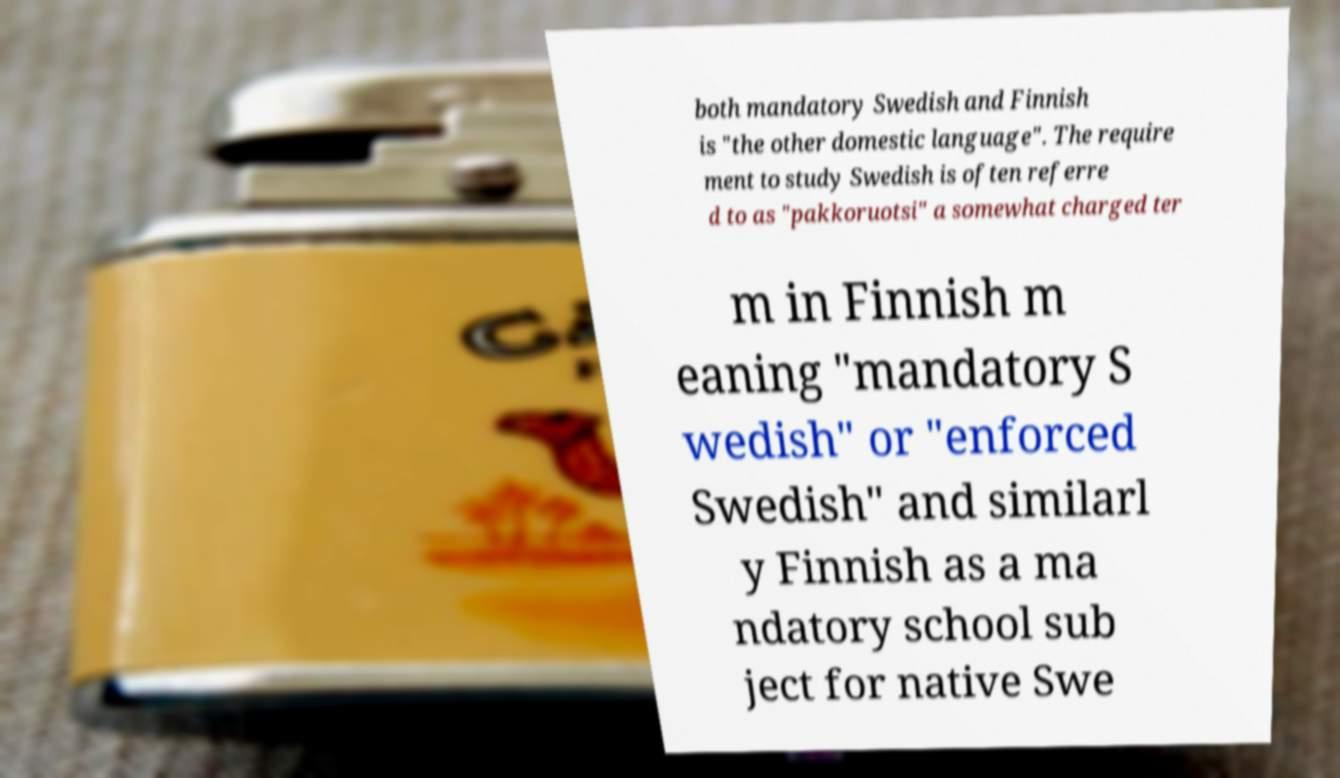Can you read and provide the text displayed in the image?This photo seems to have some interesting text. Can you extract and type it out for me? both mandatory Swedish and Finnish is "the other domestic language". The require ment to study Swedish is often referre d to as "pakkoruotsi" a somewhat charged ter m in Finnish m eaning "mandatory S wedish" or "enforced Swedish" and similarl y Finnish as a ma ndatory school sub ject for native Swe 